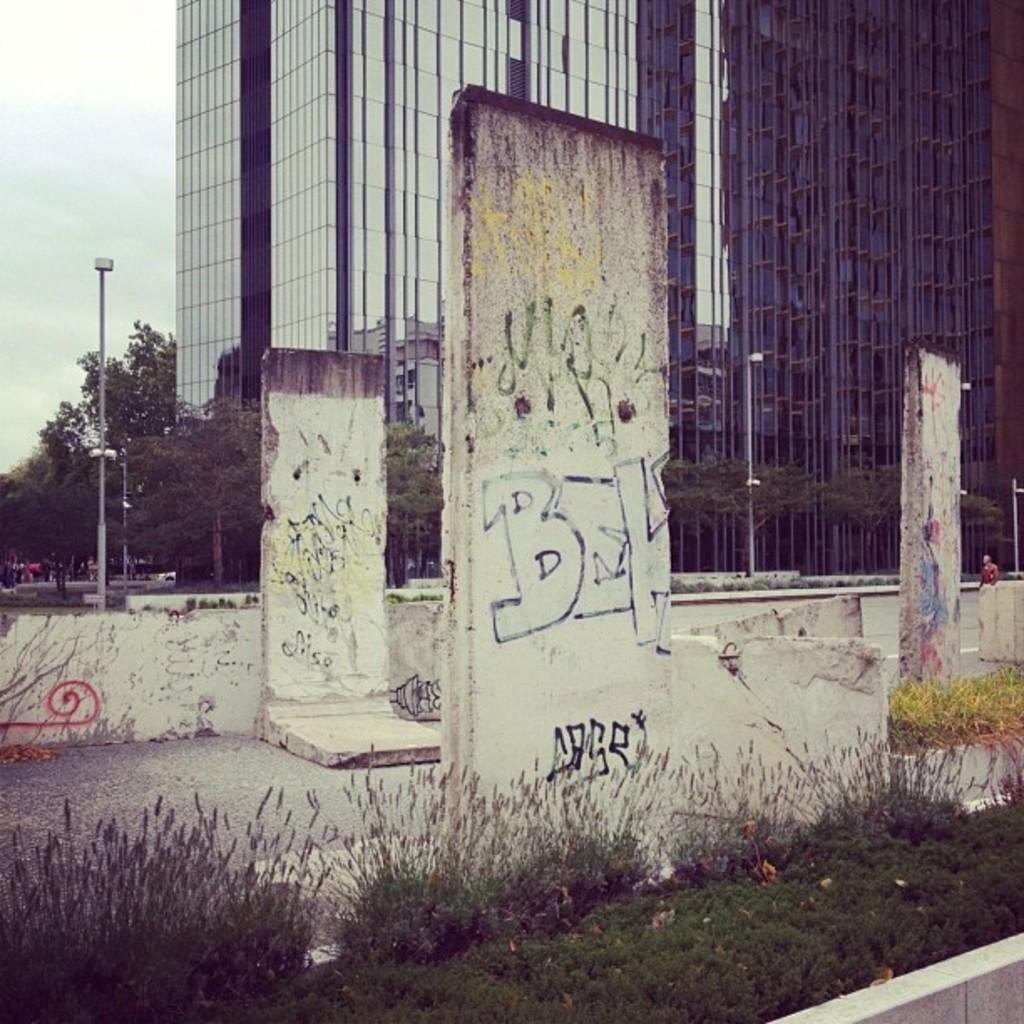What is on the stones in the image? There is graffiti on the stones in the image. What is in front of the stones? There are plants and grass in front of the stones. What can be seen in the background of the image? There is a building, trees, and light poles in the background. What type of windows does the building have? The building has glass windows. How many brothers are depicted in the graffiti on the stones? There are no brothers depicted in the graffiti on the stones, as the graffiti is not a representation of people. What is the acoustics like in the image? The acoustics cannot be determined from the image, as it does not provide any information about sound or noise levels. 